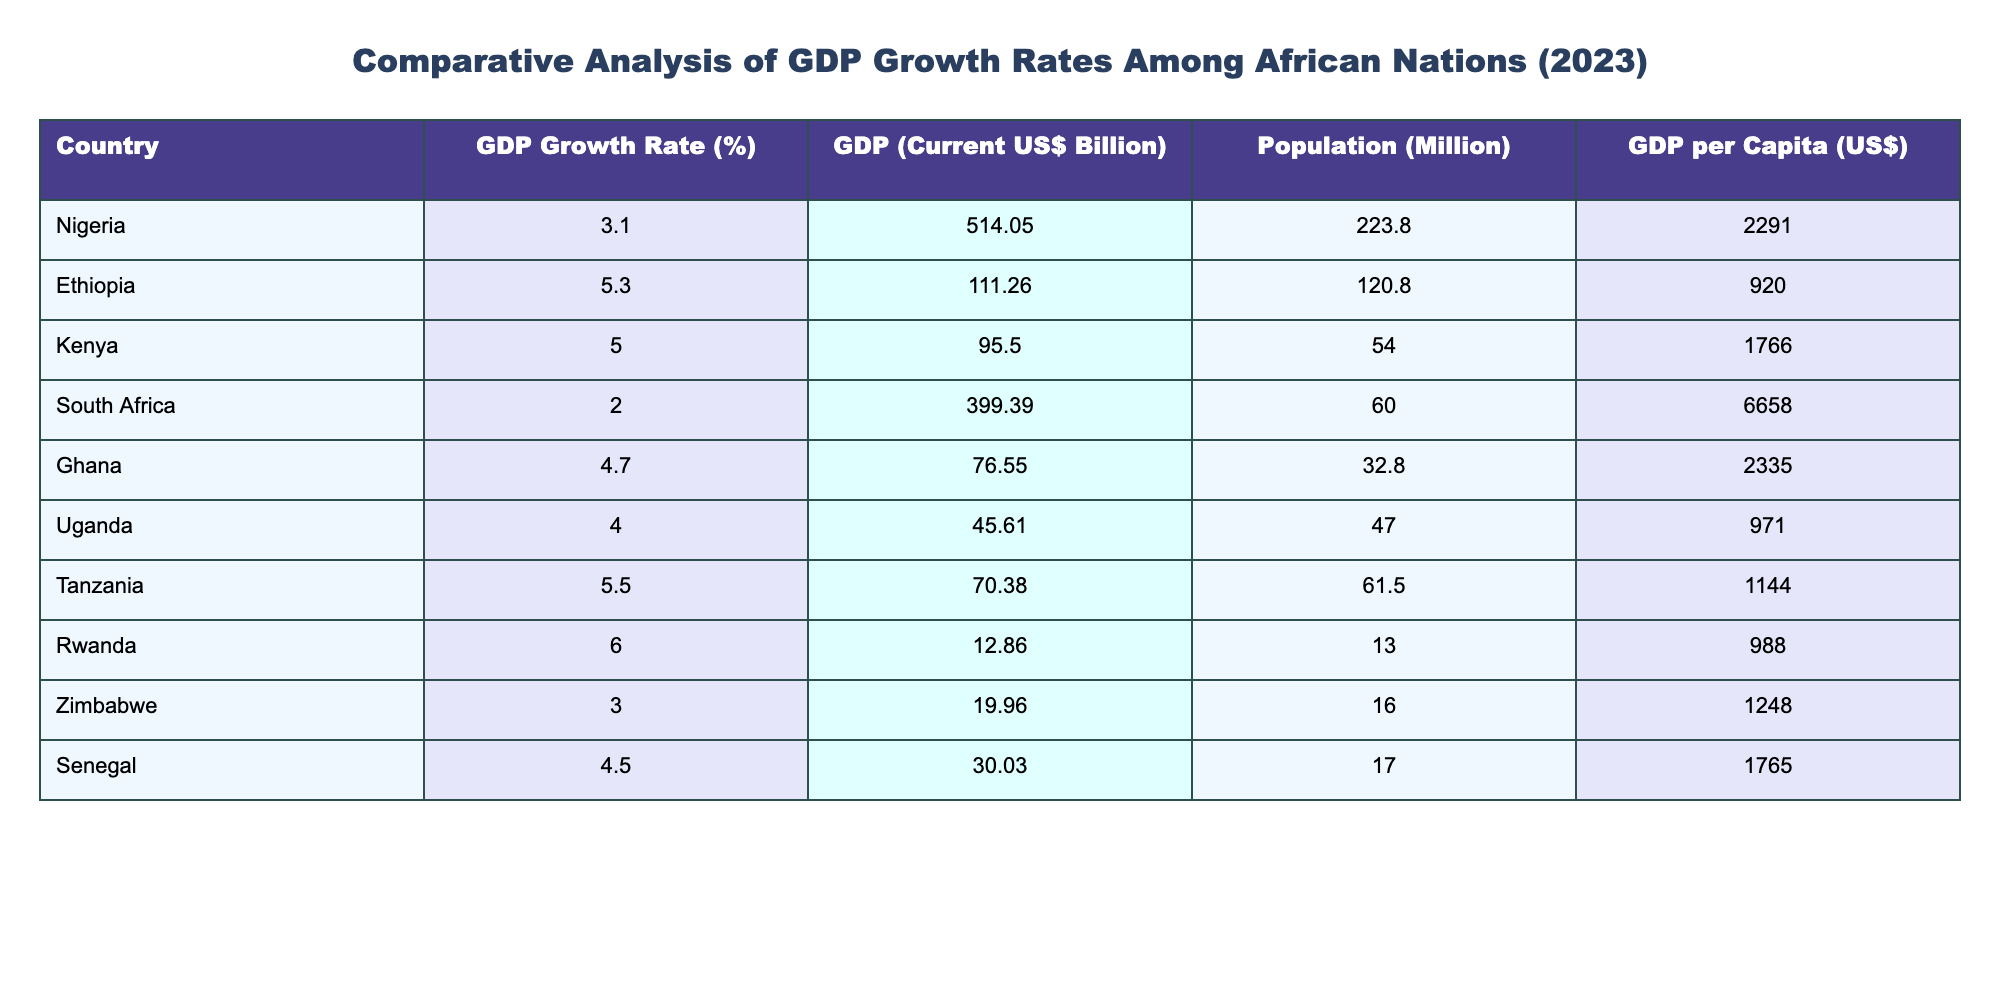What is the GDP growth rate of Ethiopia? From the table, the GDP growth rate for Ethiopia is listed directly in the row corresponding to Ethiopia as 5.3%.
Answer: 5.3% Which country has the highest GDP per capita? By comparing the GDP per capita values listed in the table, South Africa shows the highest value at 6658 US$.
Answer: 6658 What is the average GDP growth rate of Uganda and Tanzania? The GDP growth rate for Uganda is 4.0% and for Tanzania is 5.5%. To find the average, sum these rates (4.0 + 5.5 = 9.5) and divide by 2, which results in 4.75%.
Answer: 4.75% Is Nigeria's GDP growth rate higher than South Africa's? Nigeria's GDP growth rate is 3.1% and South Africa's is 2.0%. Since 3.1% is greater than 2.0%, the statement is true.
Answer: Yes Which country has both a GDP growth rate over 5% and a GDP per capita under 2000 US$? Looking at the table, Ethiopia (5.3% growth and GDP per capita 920 US$), Tanzania (5.5% growth and 1144 US$) fit this criteria. Both have GDP growth rates over 5% but their GDP per capita values are below 2000 US$.
Answer: Ethiopia and Tanzania 